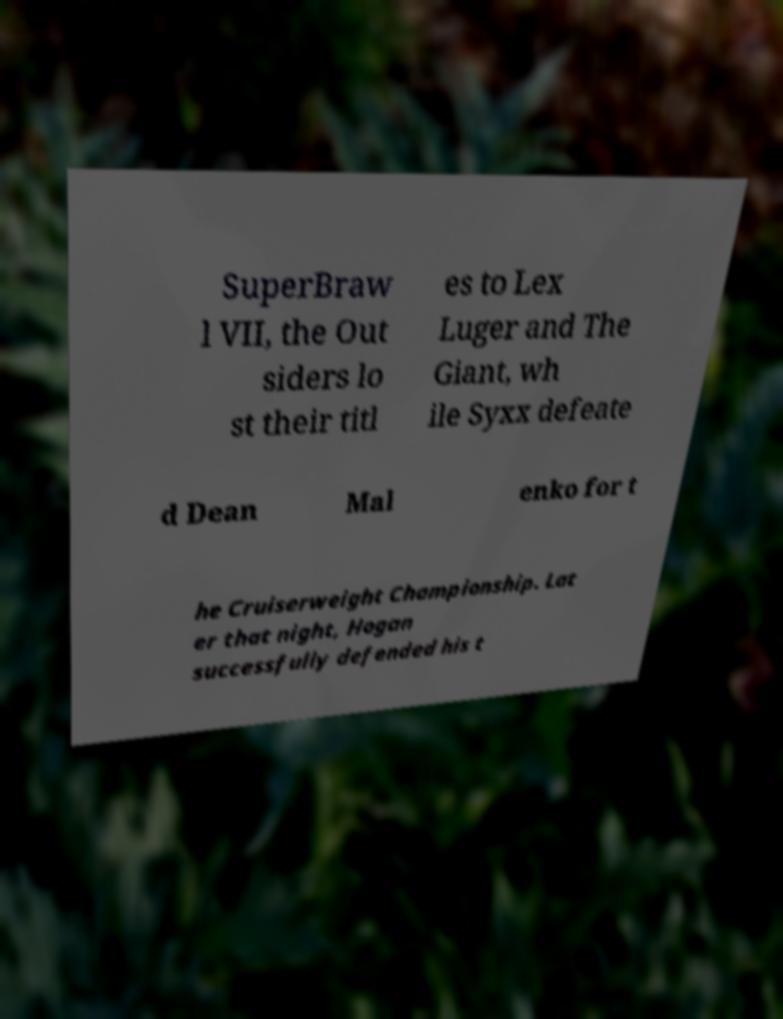Could you extract and type out the text from this image? SuperBraw l VII, the Out siders lo st their titl es to Lex Luger and The Giant, wh ile Syxx defeate d Dean Mal enko for t he Cruiserweight Championship. Lat er that night, Hogan successfully defended his t 